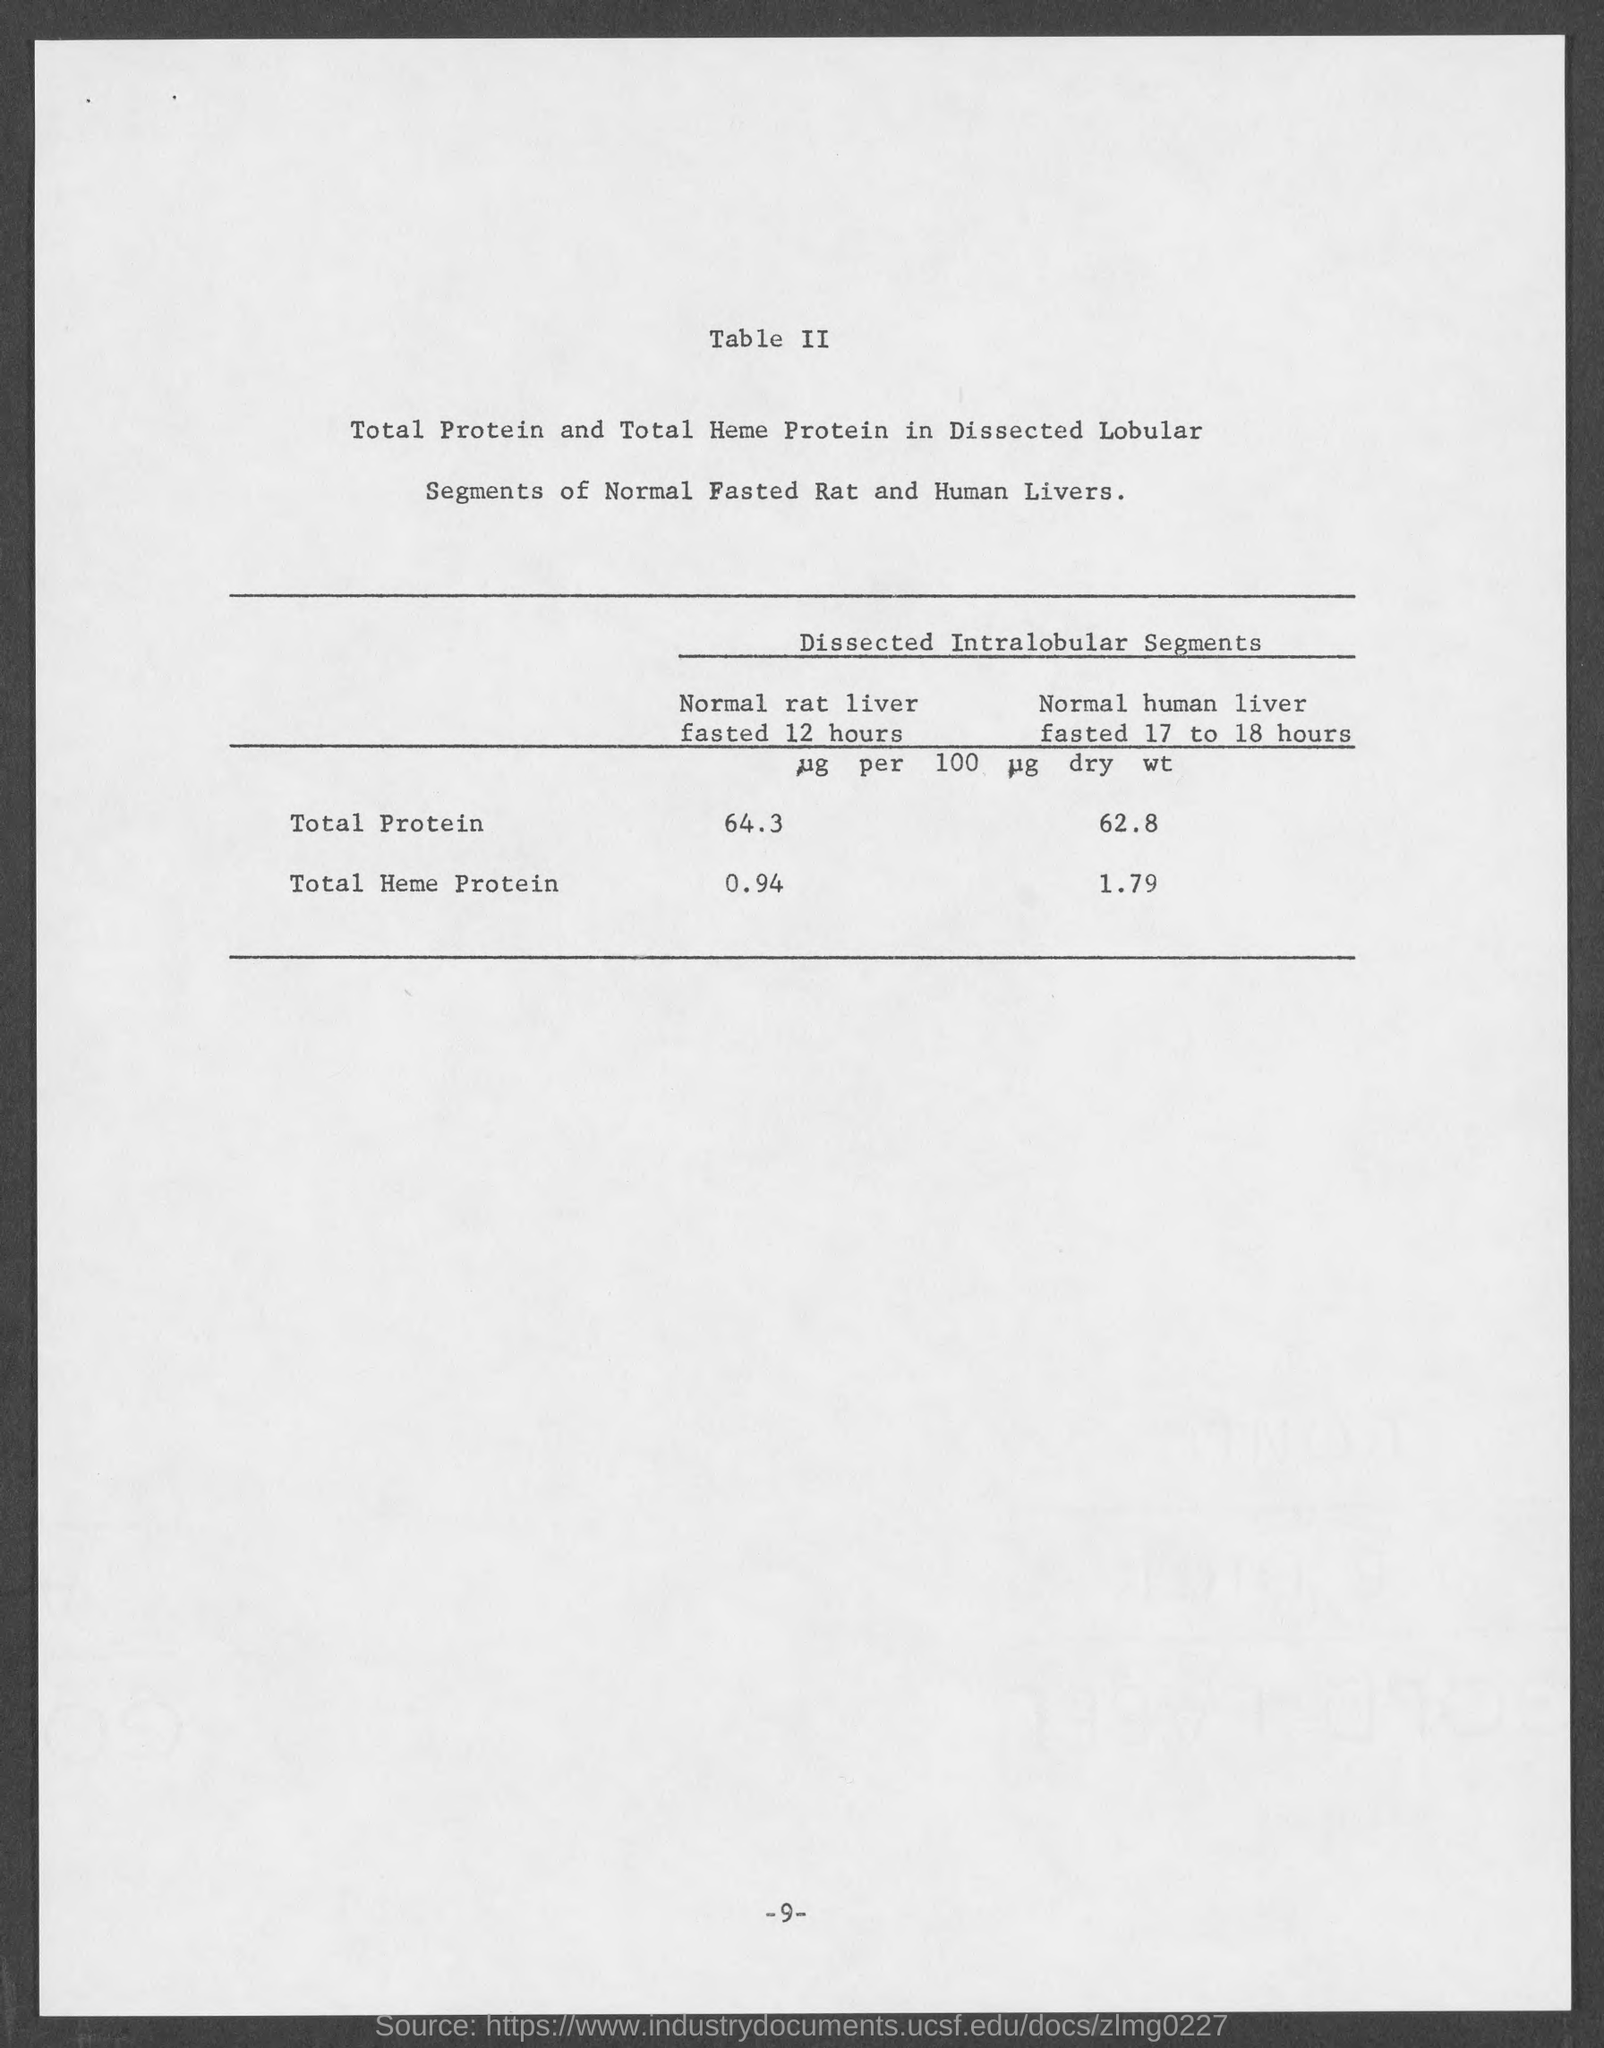What is the total protein in normal rat liver fasted 12 hours?
Offer a terse response. 64.3. What is the total protein in normal human liver fasted 17 to 18 hours ?
Keep it short and to the point. 62.8. What is the total heme protein in normal rat liver fasted 12 hours ?
Your answer should be very brief. .94. What is the total heme protein in normal human  liver fasted 17 to 18 hours ?
Ensure brevity in your answer.  1.79 ug. What is the page number at  bottom of the page ?
Ensure brevity in your answer.  9. 